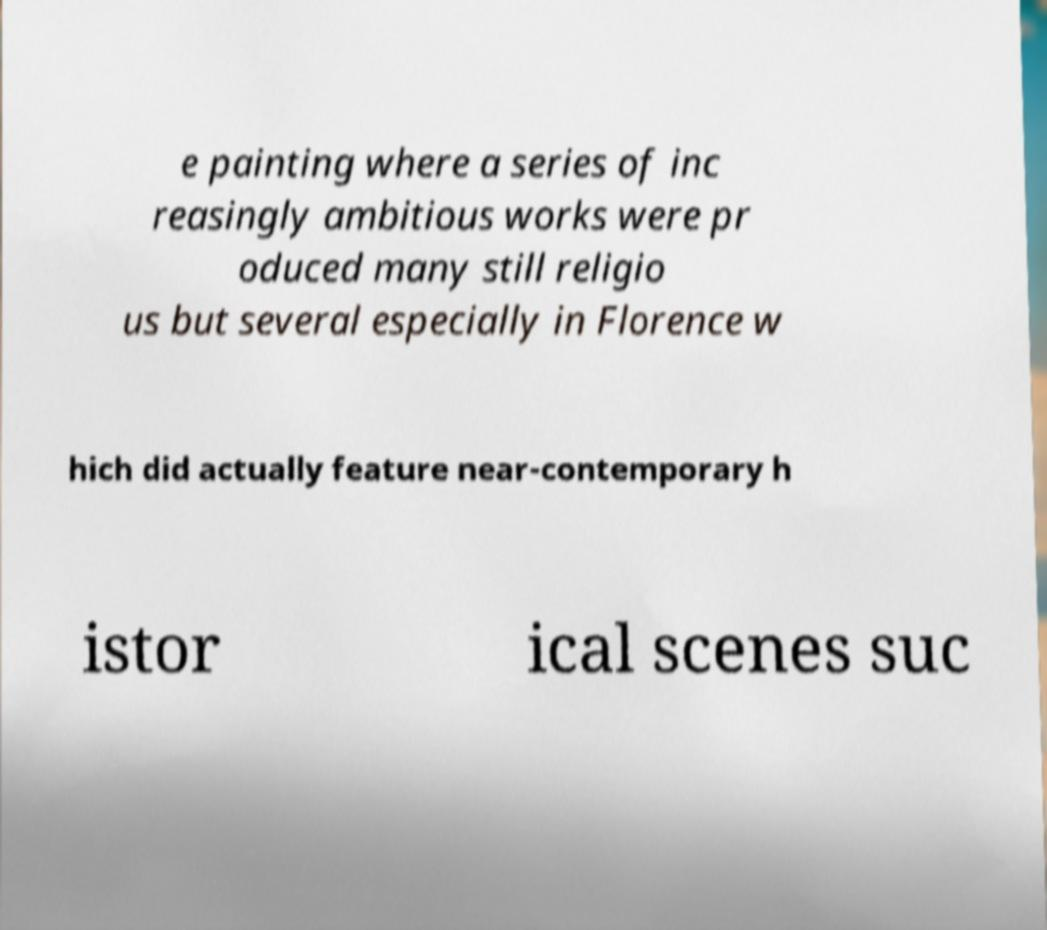Could you extract and type out the text from this image? e painting where a series of inc reasingly ambitious works were pr oduced many still religio us but several especially in Florence w hich did actually feature near-contemporary h istor ical scenes suc 